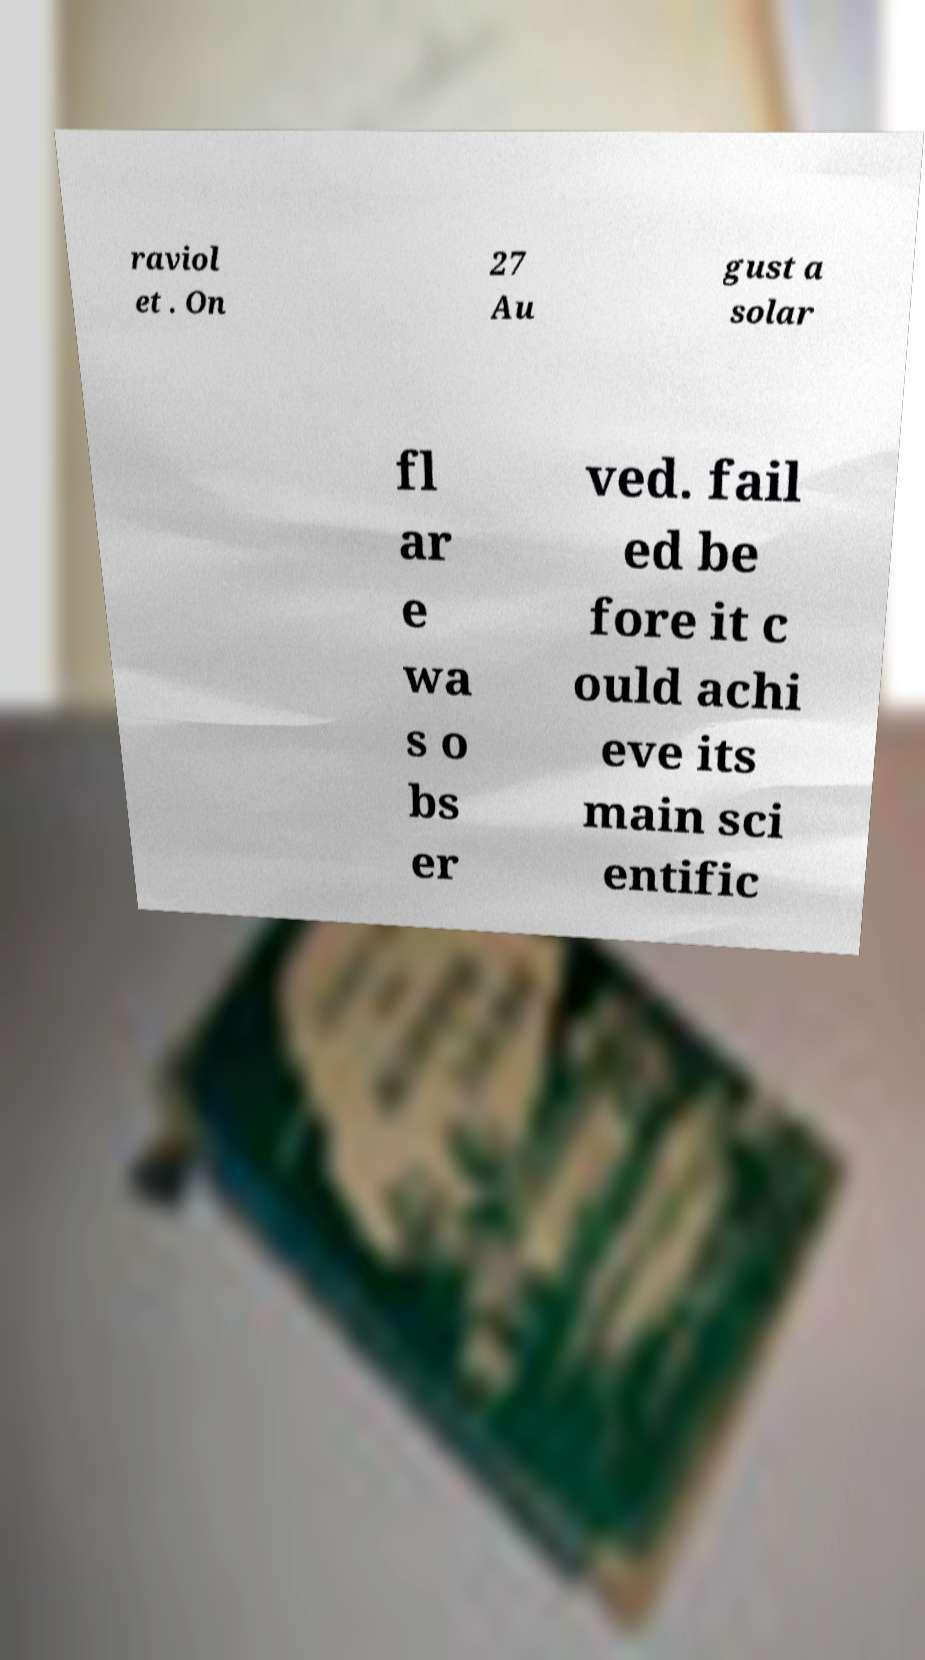Can you accurately transcribe the text from the provided image for me? raviol et . On 27 Au gust a solar fl ar e wa s o bs er ved. fail ed be fore it c ould achi eve its main sci entific 